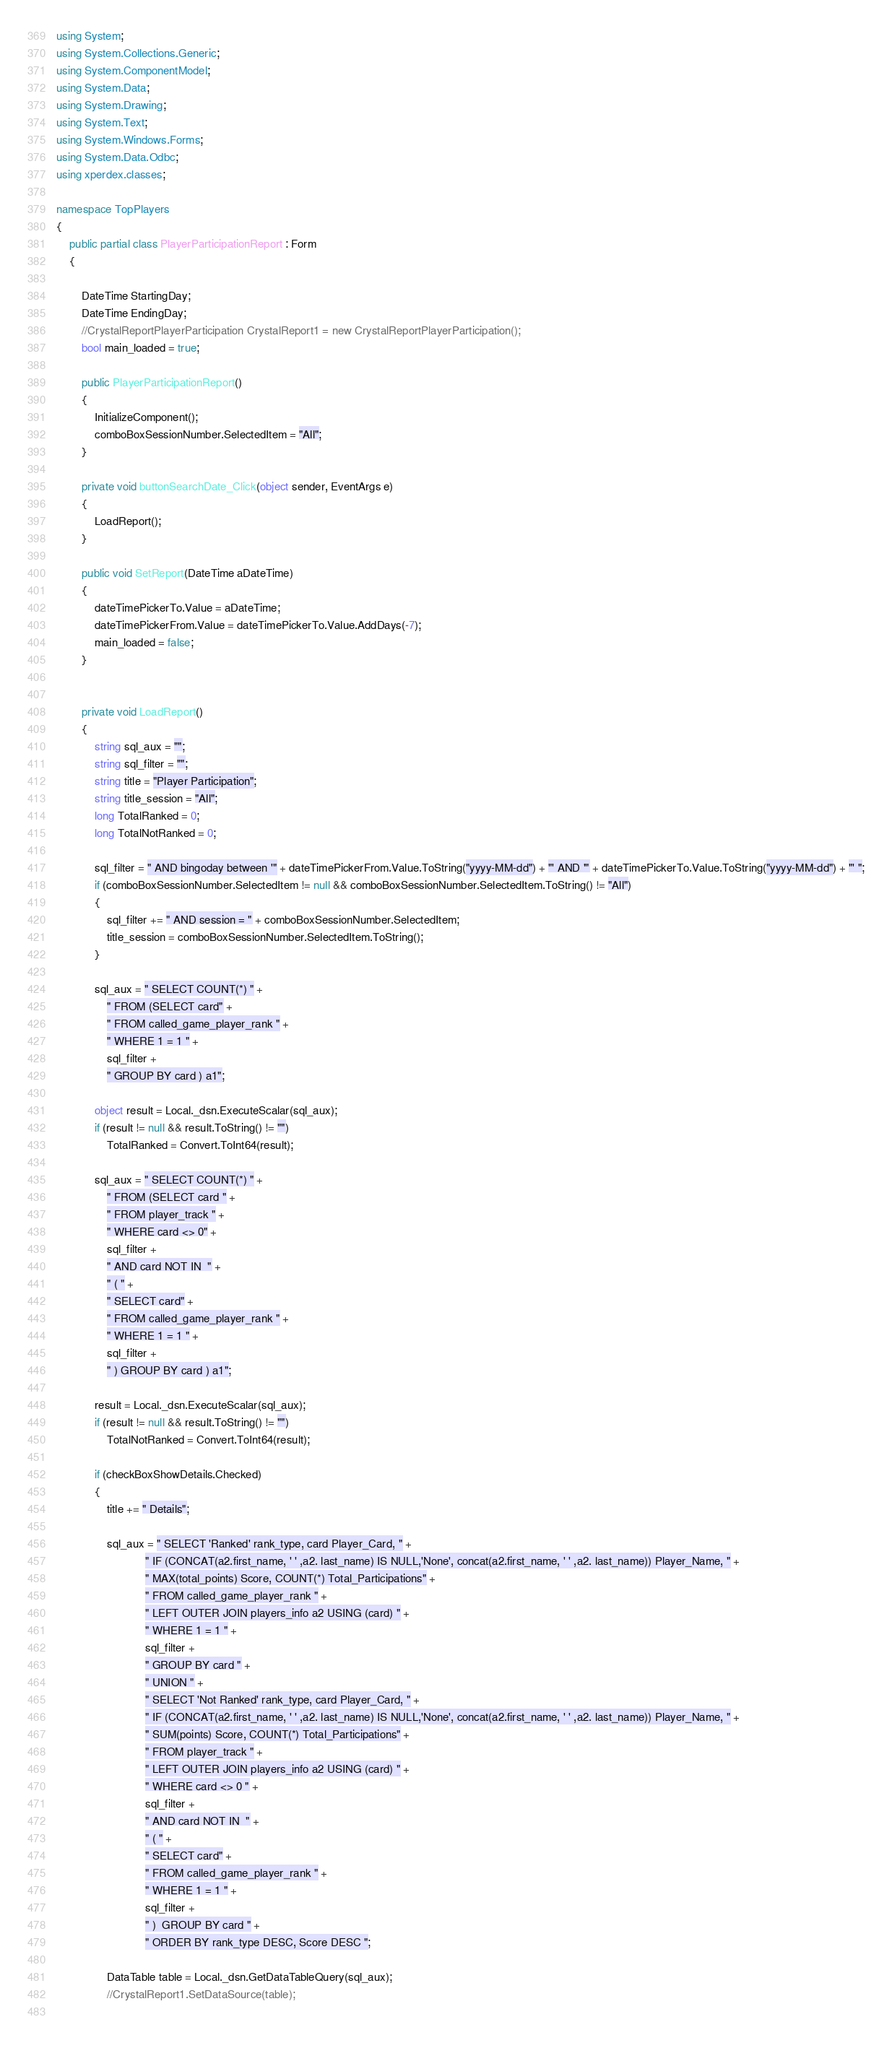<code> <loc_0><loc_0><loc_500><loc_500><_C#_>using System;
using System.Collections.Generic;
using System.ComponentModel;
using System.Data;
using System.Drawing;
using System.Text;
using System.Windows.Forms;
using System.Data.Odbc;
using xperdex.classes;

namespace TopPlayers
{
	public partial class PlayerParticipationReport : Form
	{
		
		DateTime StartingDay;
		DateTime EndingDay;
		//CrystalReportPlayerParticipation CrystalReport1 = new CrystalReportPlayerParticipation();
		bool main_loaded = true;

		public PlayerParticipationReport()
		{
			InitializeComponent();
			comboBoxSessionNumber.SelectedItem = "All";			
		}

		private void buttonSearchDate_Click(object sender, EventArgs e)
		{
			LoadReport();
		}

		public void SetReport(DateTime aDateTime)
		{
			dateTimePickerTo.Value = aDateTime;
			dateTimePickerFrom.Value = dateTimePickerTo.Value.AddDays(-7);
			main_loaded = false;
		}


		private void LoadReport()
		{
			string sql_aux = "";
			string sql_filter = "";
			string title = "Player Participation";
			string title_session = "All";
			long TotalRanked = 0;
			long TotalNotRanked = 0;

			sql_filter = " AND bingoday between '" + dateTimePickerFrom.Value.ToString("yyyy-MM-dd") + "' AND '" + dateTimePickerTo.Value.ToString("yyyy-MM-dd") + "' ";
			if (comboBoxSessionNumber.SelectedItem != null && comboBoxSessionNumber.SelectedItem.ToString() != "All")
			{
				sql_filter += " AND session = " + comboBoxSessionNumber.SelectedItem;
				title_session = comboBoxSessionNumber.SelectedItem.ToString();
			}

			sql_aux = " SELECT COUNT(*) " +
				" FROM (SELECT card" +
				" FROM called_game_player_rank " +
				" WHERE 1 = 1 " +
				sql_filter +
				" GROUP BY card ) a1";

			object result = Local._dsn.ExecuteScalar(sql_aux);
			if (result != null && result.ToString() != "")
				TotalRanked = Convert.ToInt64(result);
			
			sql_aux = " SELECT COUNT(*) " +
				" FROM (SELECT card " +
				" FROM player_track " +
				" WHERE card <> 0" +
				sql_filter +
				" AND card NOT IN  " +
				" ( " +
				" SELECT card" +
				" FROM called_game_player_rank " +
				" WHERE 1 = 1 " +
				sql_filter +
				" ) GROUP BY card ) a1";

			result = Local._dsn.ExecuteScalar(sql_aux);
			if (result != null && result.ToString() != "")
				TotalNotRanked = Convert.ToInt64(result);

			if (checkBoxShowDetails.Checked)
			{
				title += " Details";

				sql_aux = " SELECT 'Ranked' rank_type, card Player_Card, " +
							" IF (CONCAT(a2.first_name, ' ' ,a2. last_name) IS NULL,'None', concat(a2.first_name, ' ' ,a2. last_name)) Player_Name, " +
							" MAX(total_points) Score, COUNT(*) Total_Participations" +
							" FROM called_game_player_rank " +
							" LEFT OUTER JOIN players_info a2 USING (card) " +
							" WHERE 1 = 1 " +
							sql_filter +
							" GROUP BY card " +
							" UNION " +
							" SELECT 'Not Ranked' rank_type, card Player_Card, " +
							" IF (CONCAT(a2.first_name, ' ' ,a2. last_name) IS NULL,'None', concat(a2.first_name, ' ' ,a2. last_name)) Player_Name, " +
							" SUM(points) Score, COUNT(*) Total_Participations" +
							" FROM player_track " +
							" LEFT OUTER JOIN players_info a2 USING (card) " +
							" WHERE card <> 0 " +
							sql_filter +
							" AND card NOT IN  " +
							" ( " +
							" SELECT card" +
							" FROM called_game_player_rank " +
							" WHERE 1 = 1 " +
							sql_filter +
							" )  GROUP BY card " +
							" ORDER BY rank_type DESC, Score DESC ";

				DataTable table = Local._dsn.GetDataTableQuery(sql_aux);
				//CrystalReport1.SetDataSource(table);
				</code> 